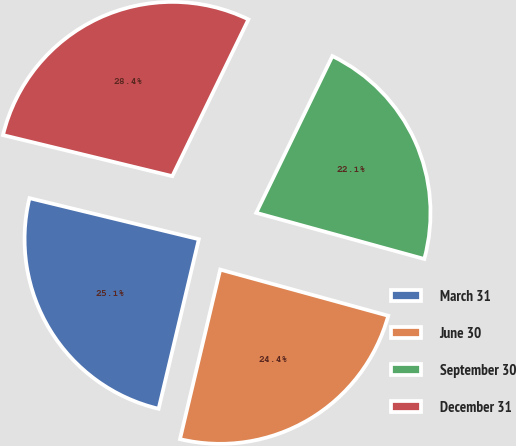Convert chart. <chart><loc_0><loc_0><loc_500><loc_500><pie_chart><fcel>March 31<fcel>June 30<fcel>September 30<fcel>December 31<nl><fcel>25.08%<fcel>24.44%<fcel>22.07%<fcel>28.41%<nl></chart> 